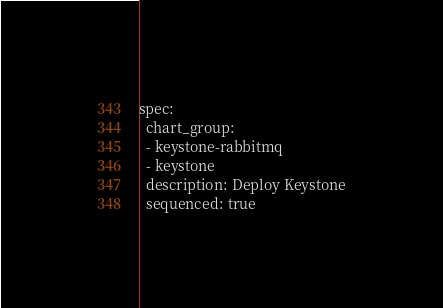Convert code to text. <code><loc_0><loc_0><loc_500><loc_500><_YAML_>spec:
  chart_group:
  - keystone-rabbitmq
  - keystone
  description: Deploy Keystone
  sequenced: true
</code> 